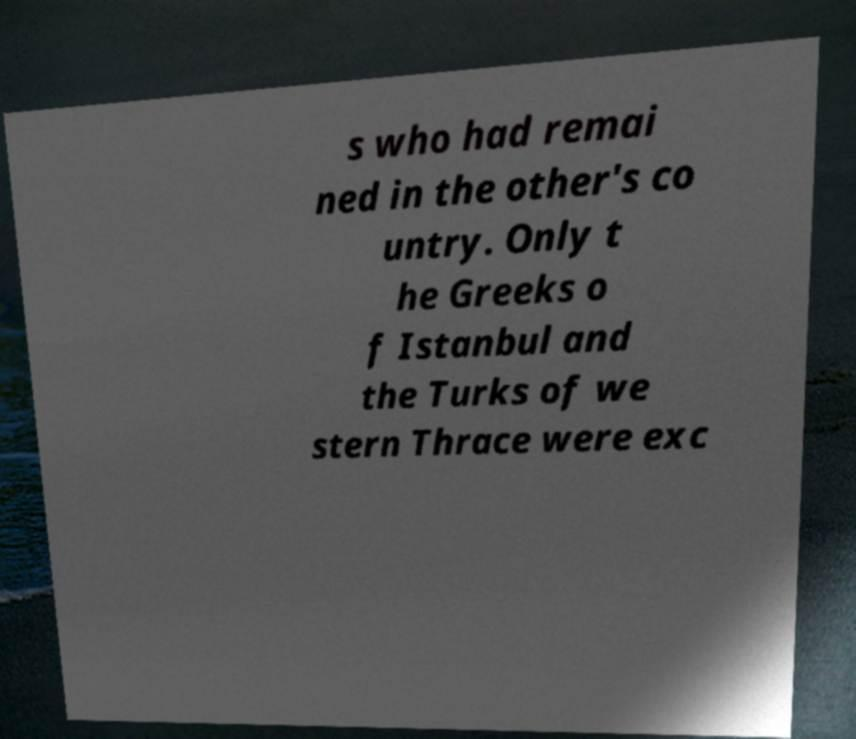What messages or text are displayed in this image? I need them in a readable, typed format. s who had remai ned in the other's co untry. Only t he Greeks o f Istanbul and the Turks of we stern Thrace were exc 